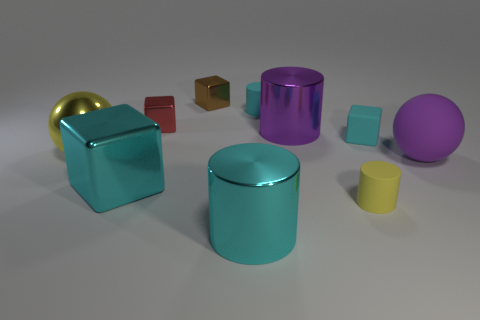The tiny cylinder that is behind the ball that is right of the cyan rubber cylinder is made of what material?
Your answer should be compact. Rubber. Are there fewer cylinders that are on the left side of the large cyan shiny cylinder than red metallic things right of the brown metal thing?
Your answer should be compact. No. What number of brown objects are small shiny things or large shiny spheres?
Provide a succinct answer. 1. Is the number of red things that are behind the small cyan cylinder the same as the number of tiny blue cylinders?
Your answer should be compact. Yes. How many objects are either small yellow cylinders or things in front of the brown shiny object?
Ensure brevity in your answer.  9. Do the matte block and the big cube have the same color?
Give a very brief answer. Yes. Is there a tiny brown block that has the same material as the big cyan cylinder?
Make the answer very short. Yes. The big matte thing that is the same shape as the large yellow metallic object is what color?
Your answer should be compact. Purple. Is the big purple sphere made of the same material as the cube that is in front of the large purple sphere?
Your answer should be very brief. No. What shape is the metal object that is in front of the cyan block on the left side of the tiny rubber cube?
Offer a very short reply. Cylinder. 